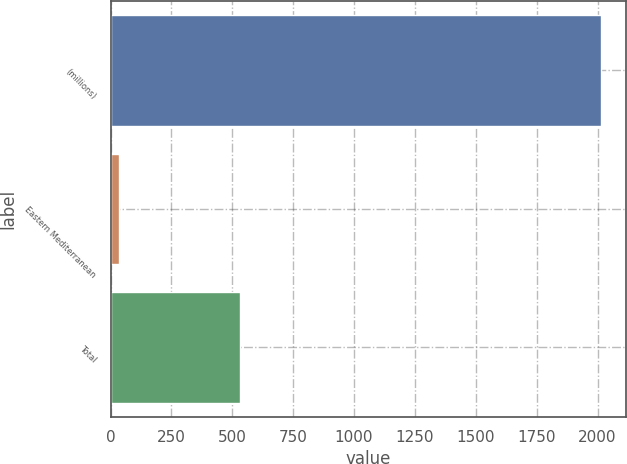Convert chart to OTSL. <chart><loc_0><loc_0><loc_500><loc_500><bar_chart><fcel>(millions)<fcel>Eastern Mediterranean<fcel>Total<nl><fcel>2015<fcel>36<fcel>533<nl></chart> 